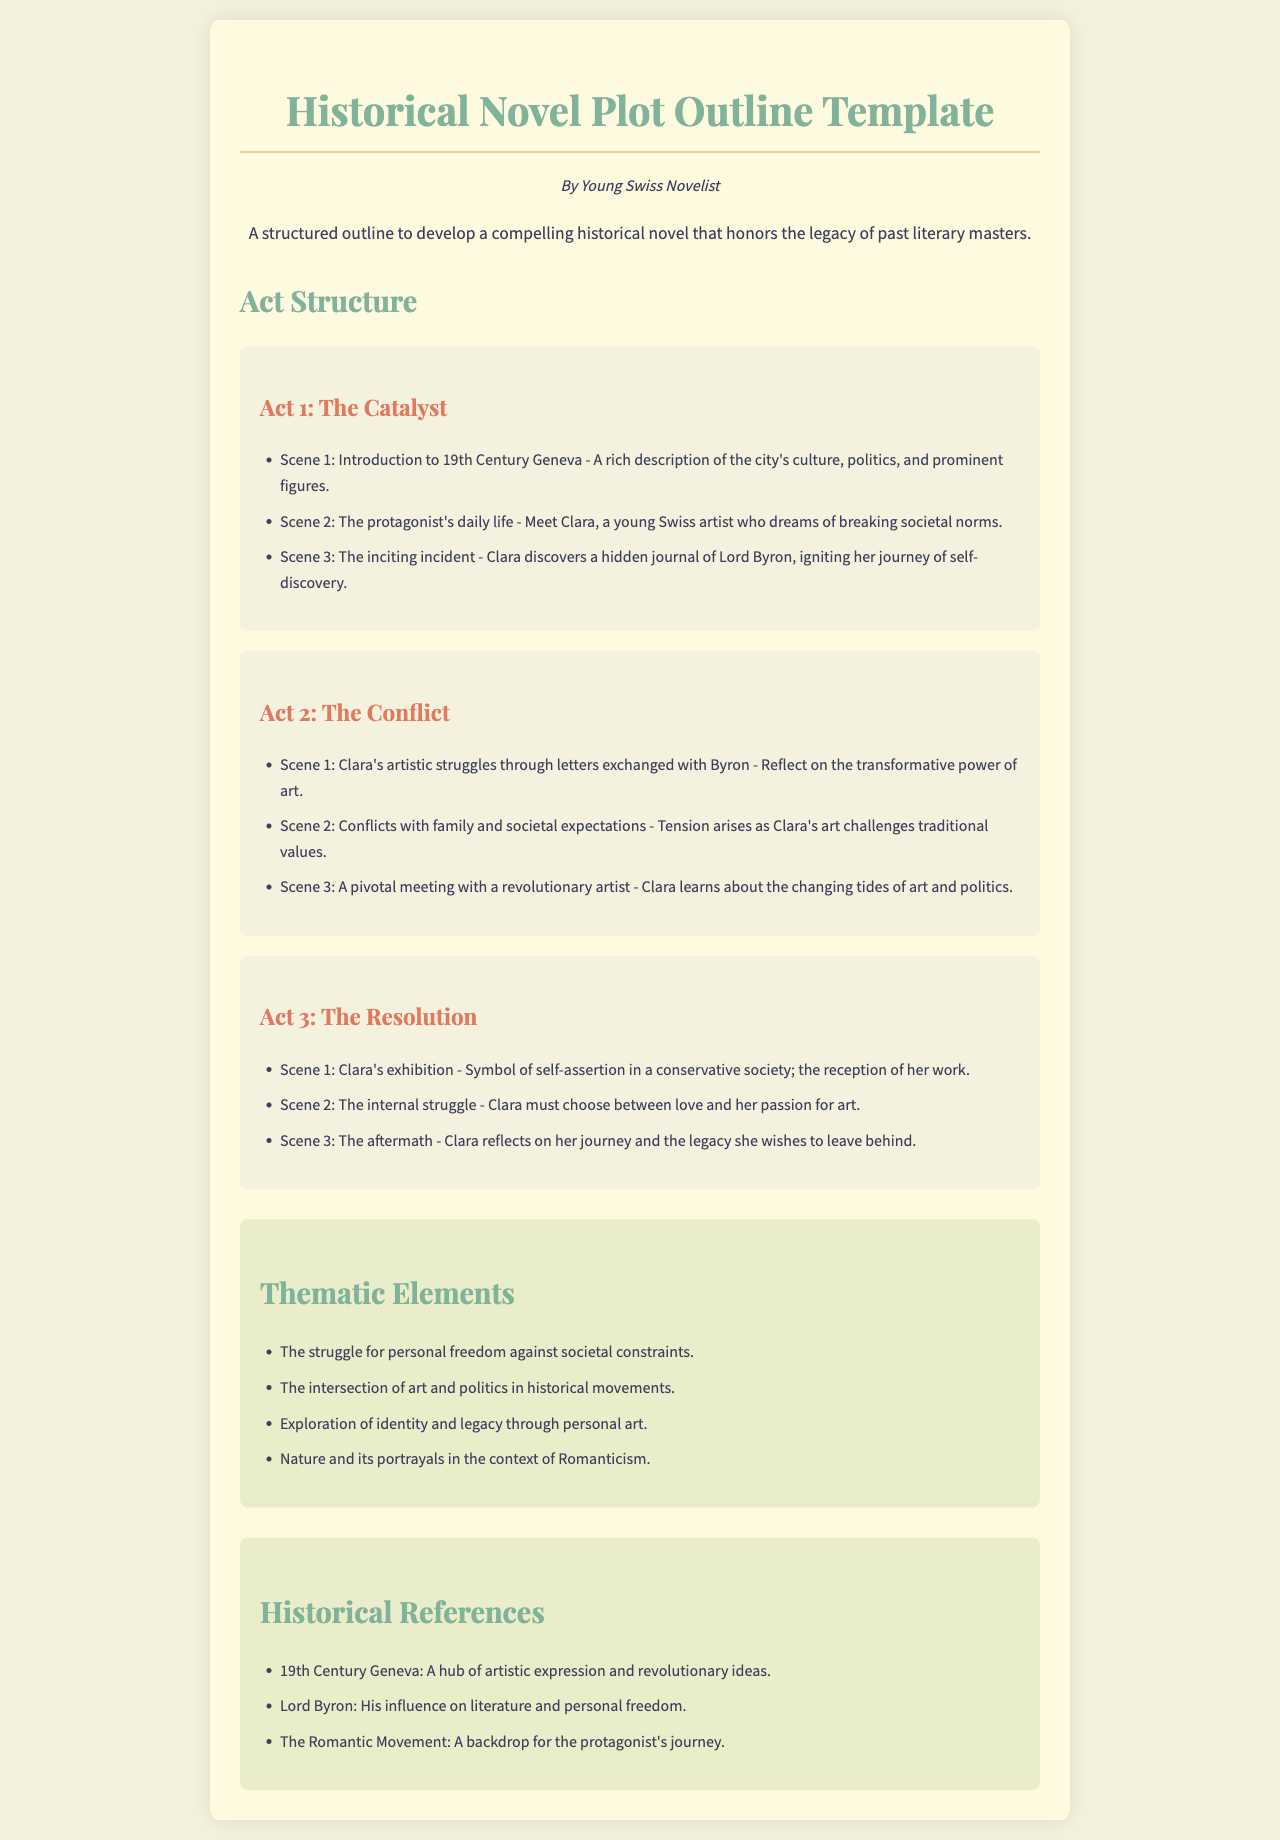What is the title of the document? The title of the document is displayed prominently at the top, presenting the subject matter clearly.
Answer: Historical Novel Plot Outline Template Who is the author of the document? The author's name is included as a subheading to give credit to the creator of the outline.
Answer: Young Swiss Novelist What is the setting of Act 1? The settings are detailed in the respective acts, particularly describing the environment where the protagonist's story begins.
Answer: 19th Century Geneva Name one thematic element mentioned in the document. The thematic elements section lists multiple themes integral to the narrative of the historical novel.
Answer: The struggle for personal freedom against societal constraints How many scenes are in Act 2? The number of scenes can be counted within the structured outline provided in each act.
Answer: 3 What personal challenge does Clara face in Act 3? The internal conflict the protagonist must confront is specified in the act summary.
Answer: Clara must choose between love and her passion for art What is the significance of Clara's exhibition? The significance of the exhibition is highlighted as a pivotal moment in the narrative arc.
Answer: Symbol of self-assertion in a conservative society Which historical figure is referenced in the document? The historical references section includes notable individuals who impact the story's themes and context.
Answer: Lord Byron 